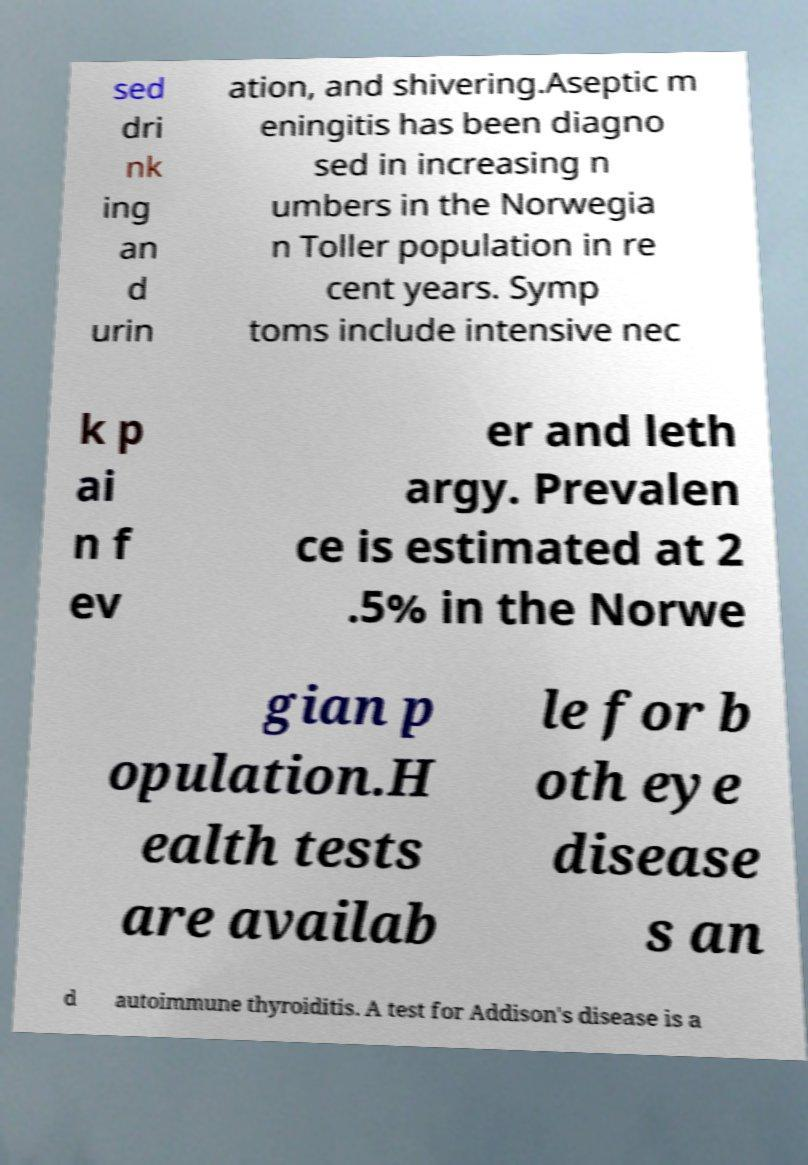Could you assist in decoding the text presented in this image and type it out clearly? sed dri nk ing an d urin ation, and shivering.Aseptic m eningitis has been diagno sed in increasing n umbers in the Norwegia n Toller population in re cent years. Symp toms include intensive nec k p ai n f ev er and leth argy. Prevalen ce is estimated at 2 .5% in the Norwe gian p opulation.H ealth tests are availab le for b oth eye disease s an d autoimmune thyroiditis. A test for Addison's disease is a 